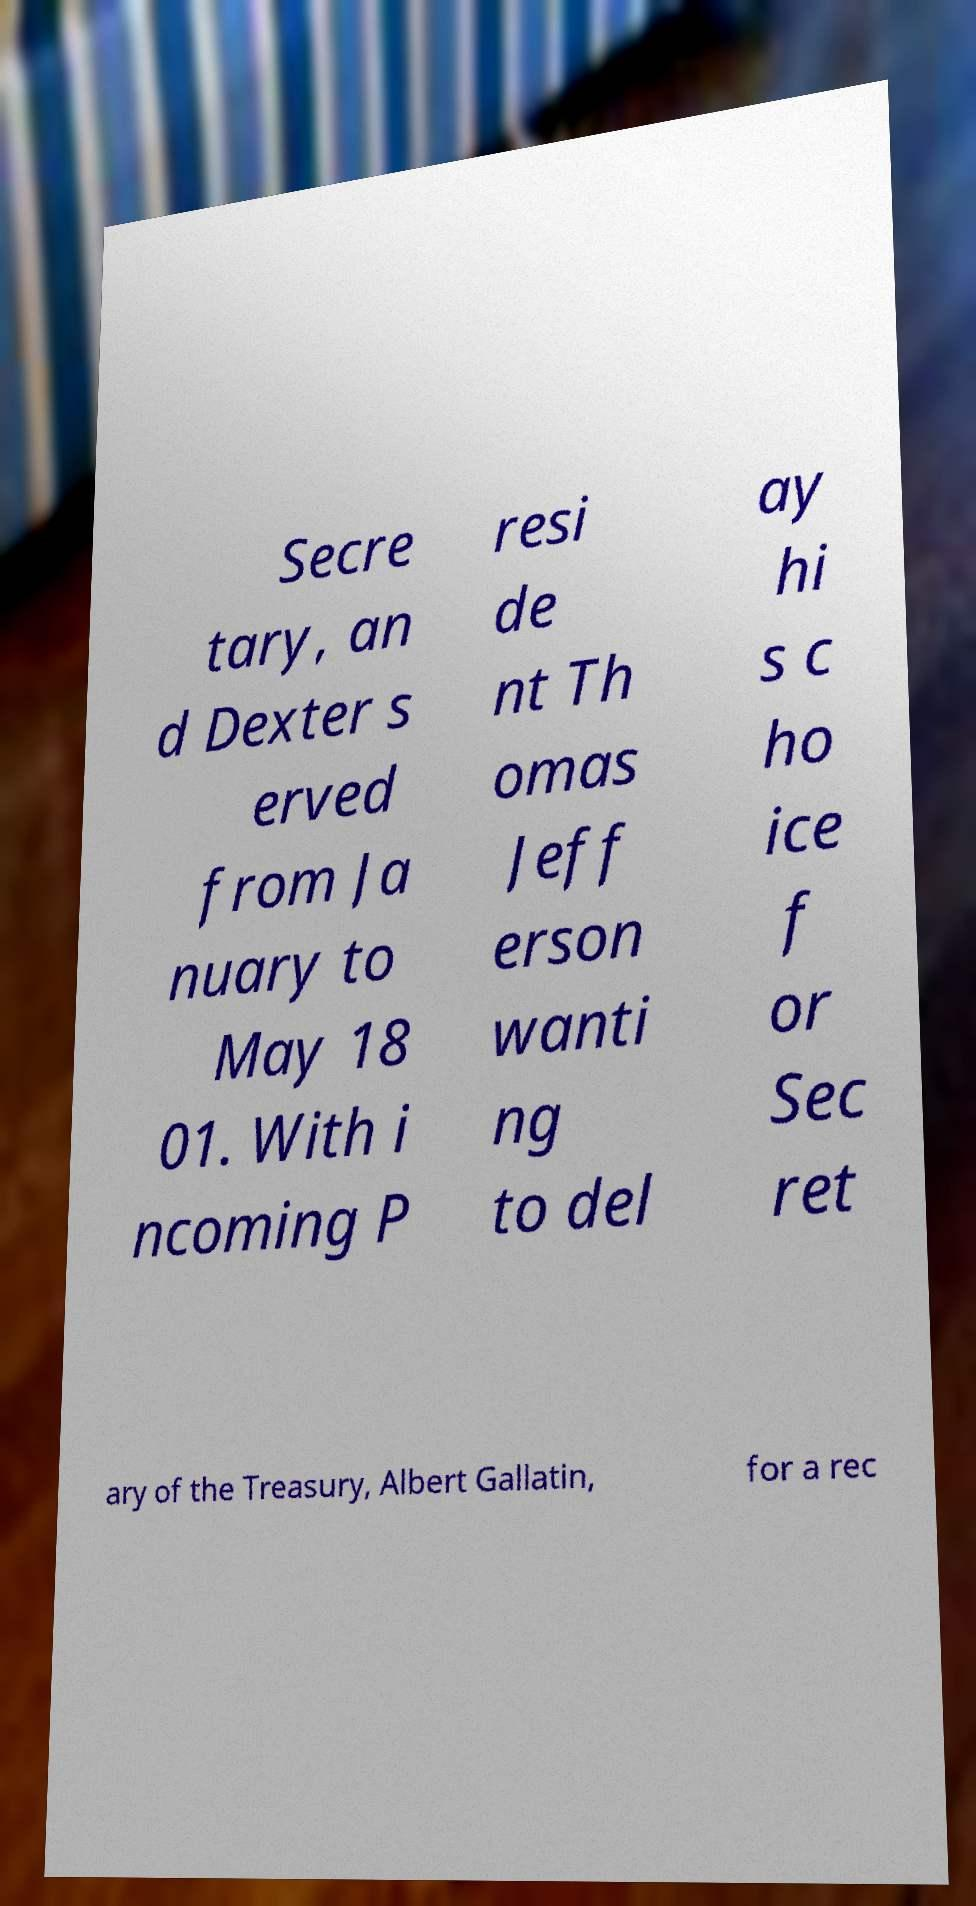Please identify and transcribe the text found in this image. Secre tary, an d Dexter s erved from Ja nuary to May 18 01. With i ncoming P resi de nt Th omas Jeff erson wanti ng to del ay hi s c ho ice f or Sec ret ary of the Treasury, Albert Gallatin, for a rec 